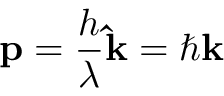Convert formula to latex. <formula><loc_0><loc_0><loc_500><loc_500>p = { \frac { h } { \lambda } } \hat { k } = \hbar { k }</formula> 